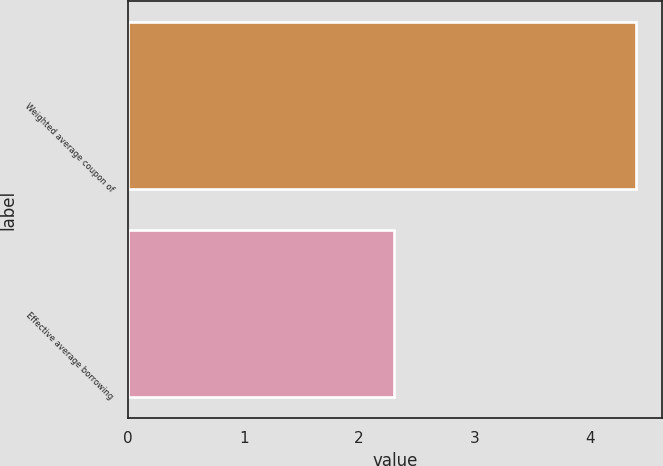<chart> <loc_0><loc_0><loc_500><loc_500><bar_chart><fcel>Weighted average coupon of<fcel>Effective average borrowing<nl><fcel>4.4<fcel>2.3<nl></chart> 